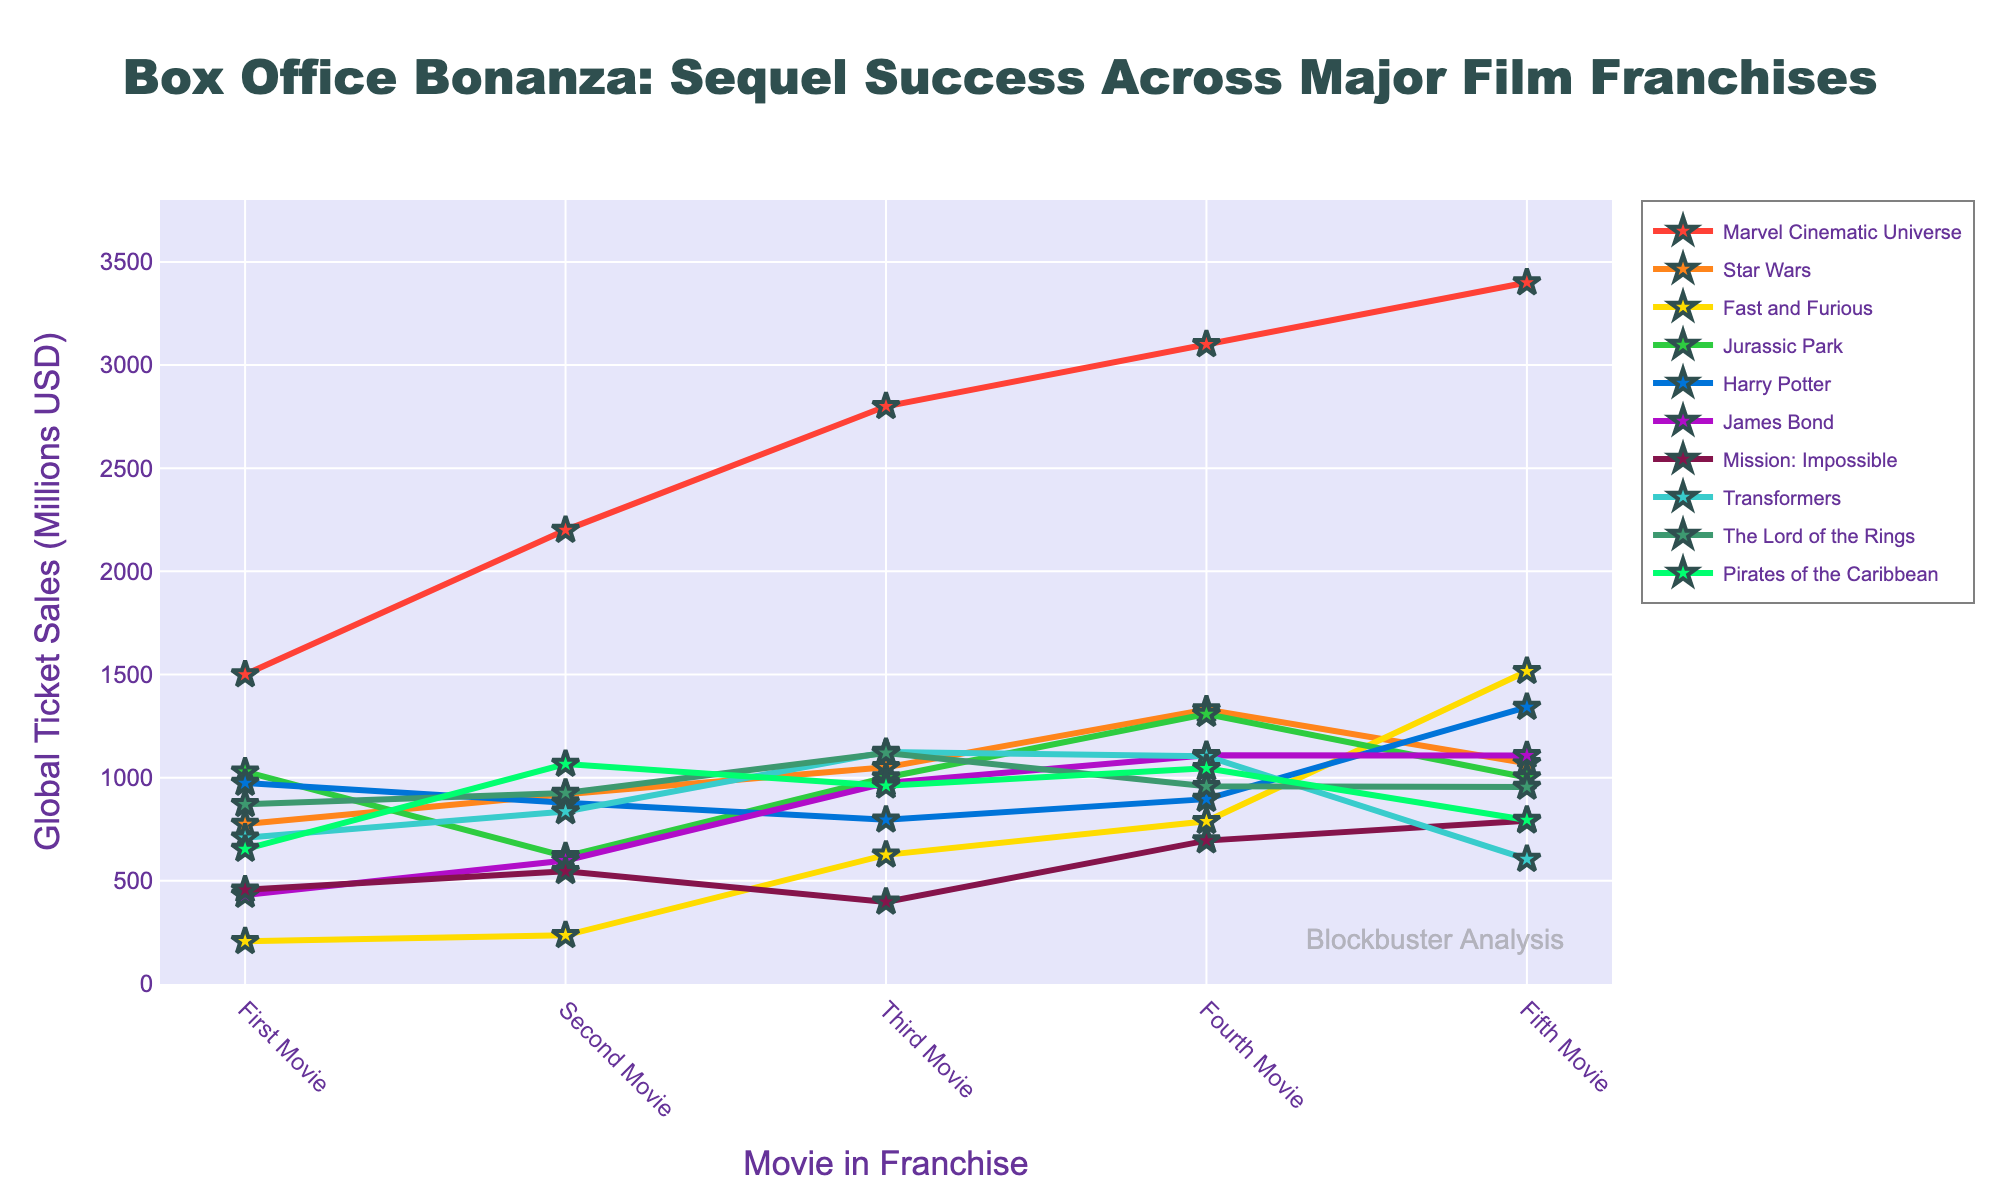What is the highest-grossing movie across all franchises? To find the highest-grossing movie, look for the highest point on the chart. The Marvel Cinematic Universe Fifth Movie has the highest value at 3400 million USD.
Answer: Marvel Cinematic Universe Fifth Movie Which franchise had a steady increase in ticket sales for every movie? Check the lines and compare the ticket sales for each movie in sequence. The Marvel Cinematic Universe shows a steady increase from the First Movie (1500) to the Fifth Movie (3400) without any drops.
Answer: Marvel Cinematic Universe What is the difference in ticket sales between the highest-grossing and lowest-grossing movies in the Fast and Furious franchise? The lowest-grossing movie in the Fast and Furious franchise is the First Movie at 207 million USD. The highest-grossing is the Fifth Movie at 1516 million USD. The difference is 1516 - 207 = 1309 million USD.
Answer: 1309 million USD By how much did the ticket sales of the third Star Wars movie exceed its first movie? The first Star Wars movie grossed 775 million USD, and the third grossed 1050 million USD. The difference is 1050 - 775 = 275 million USD.
Answer: 275 million USD Which franchise has the lowest ticket sales for its fifth movie? Look at the ticket sales for the Fifth Movie across all franchises. The Transformers franchise has the lowest value at 605 million USD.
Answer: Transformers What is the average ticket sales of the Harry Potter franchise across all five movies? Sum the values and divide by the number of movies. (974 + 879 + 796 + 896 + 1342) / 5 = 977.4 million USD.
Answer: 977.4 million USD Which franchise had a drop in sales between its first and second movie and then an increase between its second and third movie? Check each franchise's line for a downward trend followed by an upward trend. Jurassic Park dropped from 1029 million USD to 619 million USD and then increased to 1001 million USD.
Answer: Jurassic Park Which two franchises had nearly identical sales for their fifth movie? Compare the sales of the Fifth Movie. The James Bond and Jurassic Park franchises both have sales very close to 1100 million USD.
Answer: James Bond and Jurassic Park How much more did the fifth Harry Potter movie make compared to the second movie in the Pirates of the Caribbean franchise? The fifth Harry Potter movie made 1342 million USD, and the second Pirates of the Caribbean movie made 1066 million USD. The difference is 1342 - 1066 = 276 million USD.
Answer: 276 million USD What is the combined total of ticket sales for all five movies in the Mission: Impossible franchise? Sum the ticket sales for each movie in the franchise. 457 + 546 + 398 + 695 + 791 = 2887 million USD.
Answer: 2887 million USD 